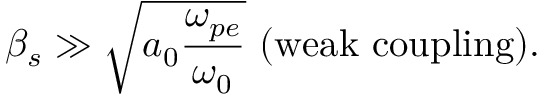<formula> <loc_0><loc_0><loc_500><loc_500>\beta _ { s } \gg \sqrt { a _ { 0 } \frac { \omega _ { p e } } { \omega _ { 0 } } } \ ( w e a k \ c o u p l i n g ) .</formula> 